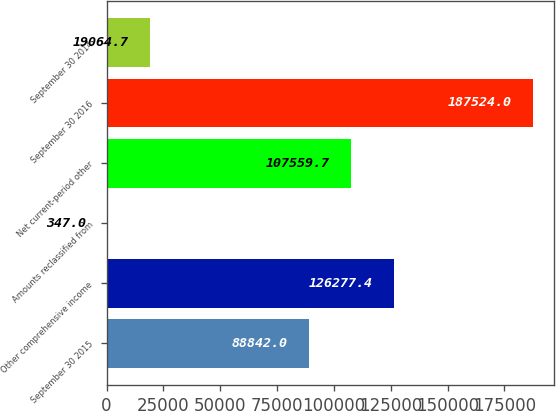<chart> <loc_0><loc_0><loc_500><loc_500><bar_chart><fcel>September 30 2015<fcel>Other comprehensive income<fcel>Amounts reclassified from<fcel>Net current-period other<fcel>September 30 2016<fcel>September 30 2014<nl><fcel>88842<fcel>126277<fcel>347<fcel>107560<fcel>187524<fcel>19064.7<nl></chart> 